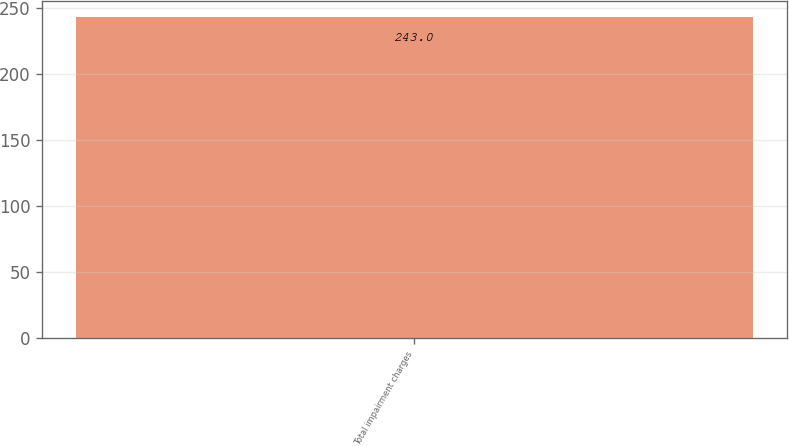Convert chart. <chart><loc_0><loc_0><loc_500><loc_500><bar_chart><fcel>Total impairment charges<nl><fcel>243<nl></chart> 